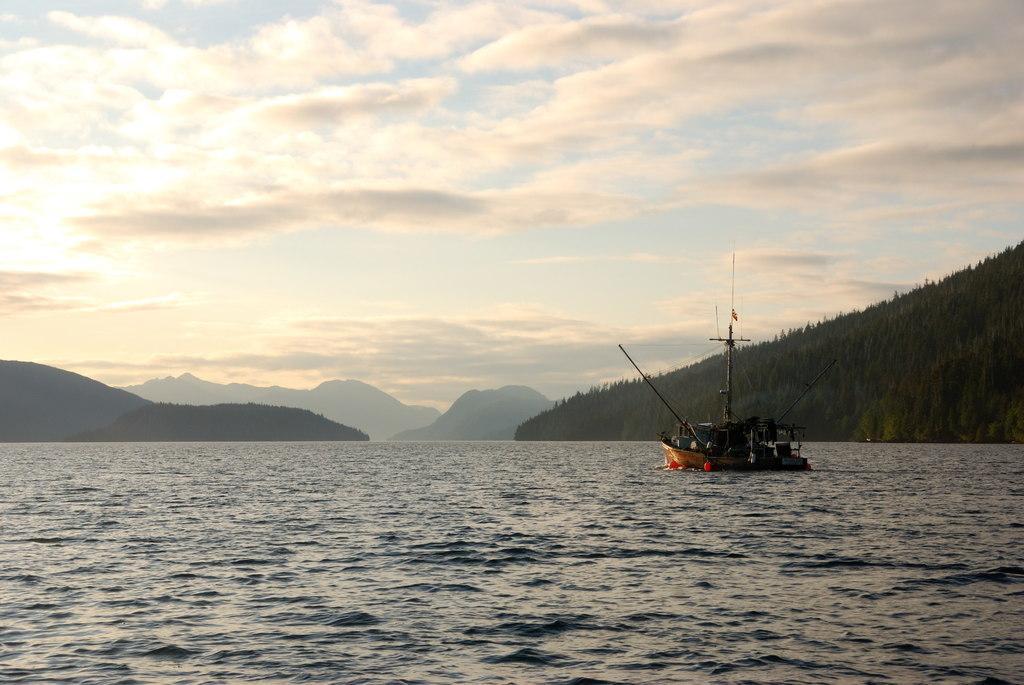Could you give a brief overview of what you see in this image? In this image, we can see a ship on the water and in the background, there are trees and hills. At the top, there are clouds in the sky. 